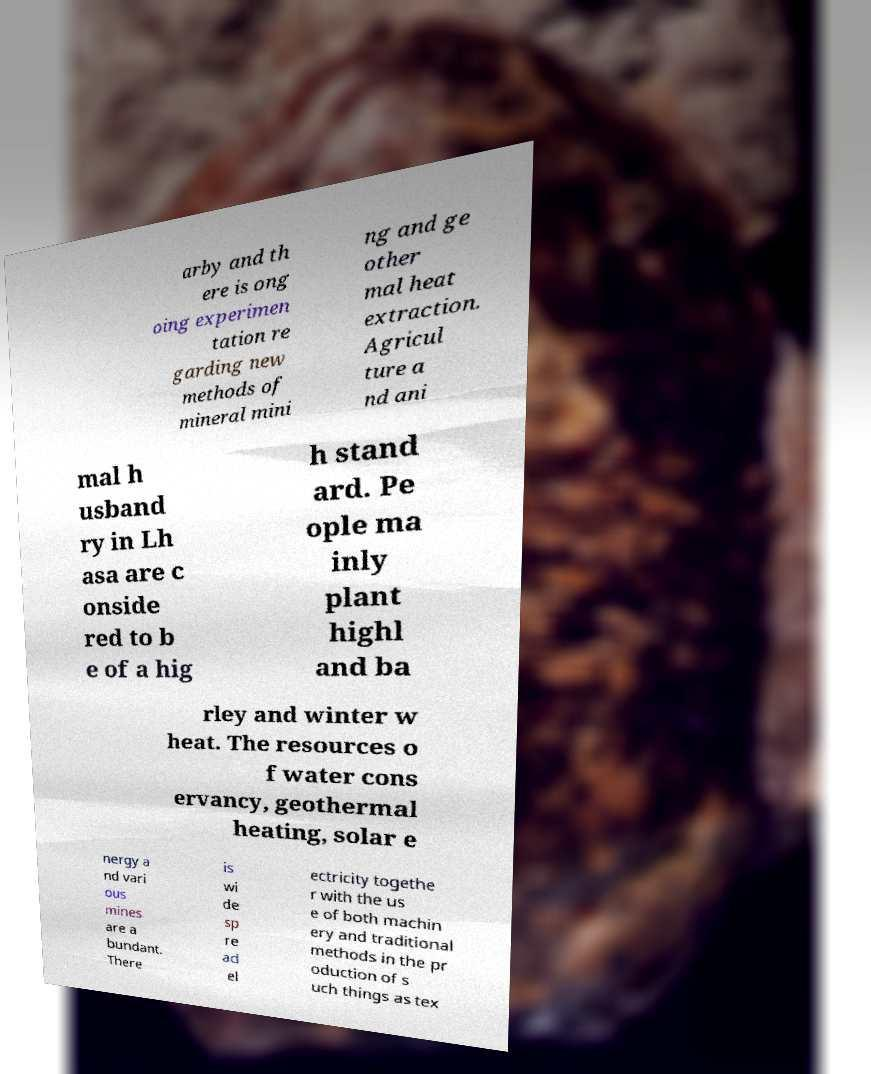Could you assist in decoding the text presented in this image and type it out clearly? arby and th ere is ong oing experimen tation re garding new methods of mineral mini ng and ge other mal heat extraction. Agricul ture a nd ani mal h usband ry in Lh asa are c onside red to b e of a hig h stand ard. Pe ople ma inly plant highl and ba rley and winter w heat. The resources o f water cons ervancy, geothermal heating, solar e nergy a nd vari ous mines are a bundant. There is wi de sp re ad el ectricity togethe r with the us e of both machin ery and traditional methods in the pr oduction of s uch things as tex 